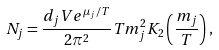<formula> <loc_0><loc_0><loc_500><loc_500>N _ { j } = \frac { d _ { j } V e ^ { \mu _ { j } / T } } { 2 \pi ^ { 2 } } T m _ { j } ^ { 2 } K _ { 2 } \left ( \frac { m _ { j } } { T } \right ) ,</formula> 